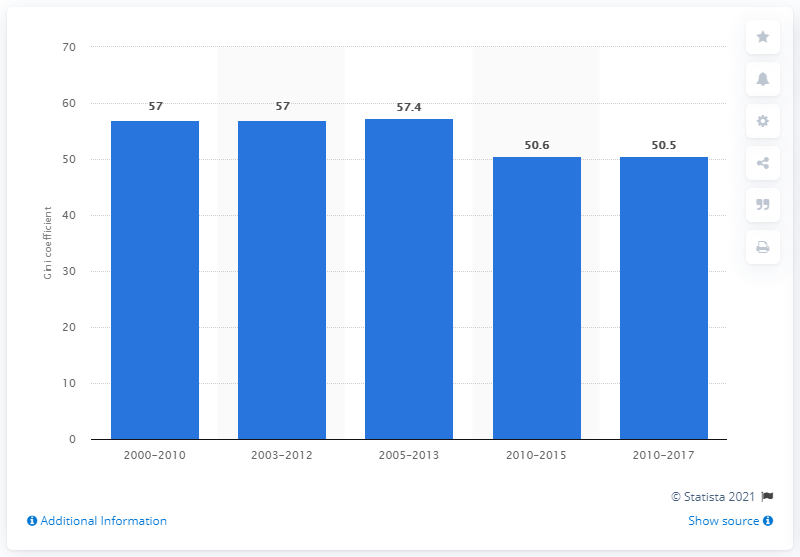Identify some key points in this picture. According to data from 2017, Honduras' Gini coefficient was 50.5, indicating a high level of income inequality within the country. 